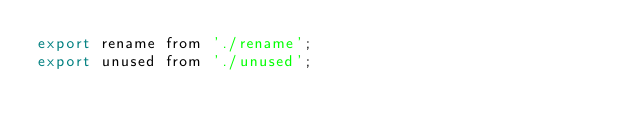<code> <loc_0><loc_0><loc_500><loc_500><_JavaScript_>export rename from './rename';
export unused from './unused';
</code> 